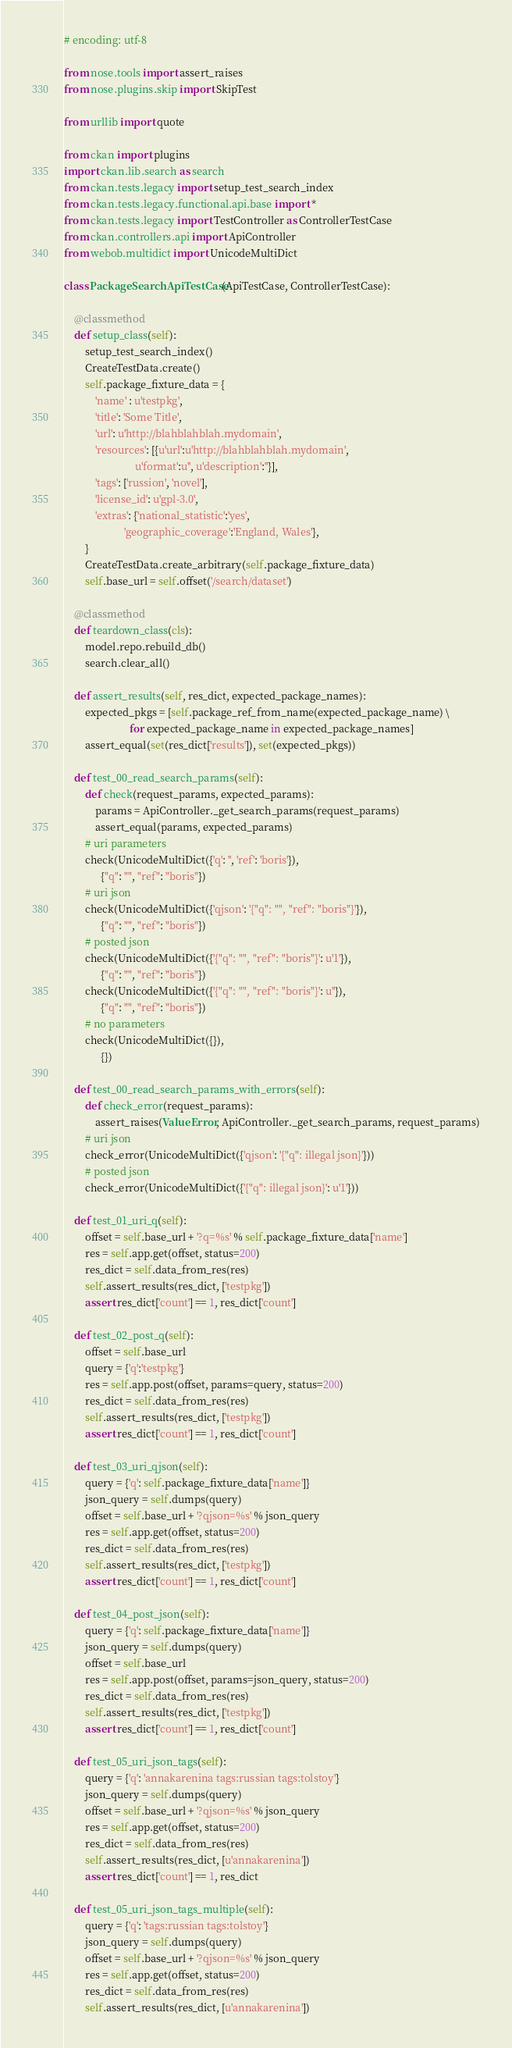Convert code to text. <code><loc_0><loc_0><loc_500><loc_500><_Python_># encoding: utf-8

from nose.tools import assert_raises
from nose.plugins.skip import SkipTest

from urllib import quote

from ckan import plugins
import ckan.lib.search as search
from ckan.tests.legacy import setup_test_search_index
from ckan.tests.legacy.functional.api.base import *
from ckan.tests.legacy import TestController as ControllerTestCase
from ckan.controllers.api import ApiController
from webob.multidict import UnicodeMultiDict

class PackageSearchApiTestCase(ApiTestCase, ControllerTestCase):

    @classmethod
    def setup_class(self):
        setup_test_search_index()
        CreateTestData.create()
        self.package_fixture_data = {
            'name' : u'testpkg',
            'title': 'Some Title',
            'url': u'http://blahblahblah.mydomain',
            'resources': [{u'url':u'http://blahblahblah.mydomain',
                           u'format':u'', u'description':''}],
            'tags': ['russion', 'novel'],
            'license_id': u'gpl-3.0',
            'extras': {'national_statistic':'yes',
                       'geographic_coverage':'England, Wales'},
        }
        CreateTestData.create_arbitrary(self.package_fixture_data)
        self.base_url = self.offset('/search/dataset')

    @classmethod
    def teardown_class(cls):
        model.repo.rebuild_db()
        search.clear_all()

    def assert_results(self, res_dict, expected_package_names):
        expected_pkgs = [self.package_ref_from_name(expected_package_name) \
                         for expected_package_name in expected_package_names]
        assert_equal(set(res_dict['results']), set(expected_pkgs))

    def test_00_read_search_params(self):
        def check(request_params, expected_params):
            params = ApiController._get_search_params(request_params)
            assert_equal(params, expected_params)
        # uri parameters
        check(UnicodeMultiDict({'q': '', 'ref': 'boris'}),
              {"q": "", "ref": "boris"})
        # uri json
        check(UnicodeMultiDict({'qjson': '{"q": "", "ref": "boris"}'}),
              {"q": "", "ref": "boris"})
        # posted json
        check(UnicodeMultiDict({'{"q": "", "ref": "boris"}': u'1'}),
              {"q": "", "ref": "boris"})
        check(UnicodeMultiDict({'{"q": "", "ref": "boris"}': u''}),
              {"q": "", "ref": "boris"})
        # no parameters
        check(UnicodeMultiDict({}),
              {})

    def test_00_read_search_params_with_errors(self):
        def check_error(request_params):
            assert_raises(ValueError, ApiController._get_search_params, request_params)
        # uri json
        check_error(UnicodeMultiDict({'qjson': '{"q": illegal json}'}))
        # posted json
        check_error(UnicodeMultiDict({'{"q": illegal json}': u'1'}))

    def test_01_uri_q(self):
        offset = self.base_url + '?q=%s' % self.package_fixture_data['name']
        res = self.app.get(offset, status=200)
        res_dict = self.data_from_res(res)
        self.assert_results(res_dict, ['testpkg'])
        assert res_dict['count'] == 1, res_dict['count']

    def test_02_post_q(self):
        offset = self.base_url
        query = {'q':'testpkg'}
        res = self.app.post(offset, params=query, status=200)
        res_dict = self.data_from_res(res)
        self.assert_results(res_dict, ['testpkg'])
        assert res_dict['count'] == 1, res_dict['count']

    def test_03_uri_qjson(self):
        query = {'q': self.package_fixture_data['name']}
        json_query = self.dumps(query)
        offset = self.base_url + '?qjson=%s' % json_query
        res = self.app.get(offset, status=200)
        res_dict = self.data_from_res(res)
        self.assert_results(res_dict, ['testpkg'])
        assert res_dict['count'] == 1, res_dict['count']

    def test_04_post_json(self):
        query = {'q': self.package_fixture_data['name']}
        json_query = self.dumps(query)
        offset = self.base_url
        res = self.app.post(offset, params=json_query, status=200)
        res_dict = self.data_from_res(res)
        self.assert_results(res_dict, ['testpkg'])
        assert res_dict['count'] == 1, res_dict['count']

    def test_05_uri_json_tags(self):
        query = {'q': 'annakarenina tags:russian tags:tolstoy'}
        json_query = self.dumps(query)
        offset = self.base_url + '?qjson=%s' % json_query
        res = self.app.get(offset, status=200)
        res_dict = self.data_from_res(res)
        self.assert_results(res_dict, [u'annakarenina'])
        assert res_dict['count'] == 1, res_dict

    def test_05_uri_json_tags_multiple(self):
        query = {'q': 'tags:russian tags:tolstoy'}
        json_query = self.dumps(query)
        offset = self.base_url + '?qjson=%s' % json_query
        res = self.app.get(offset, status=200)
        res_dict = self.data_from_res(res)
        self.assert_results(res_dict, [u'annakarenina'])</code> 